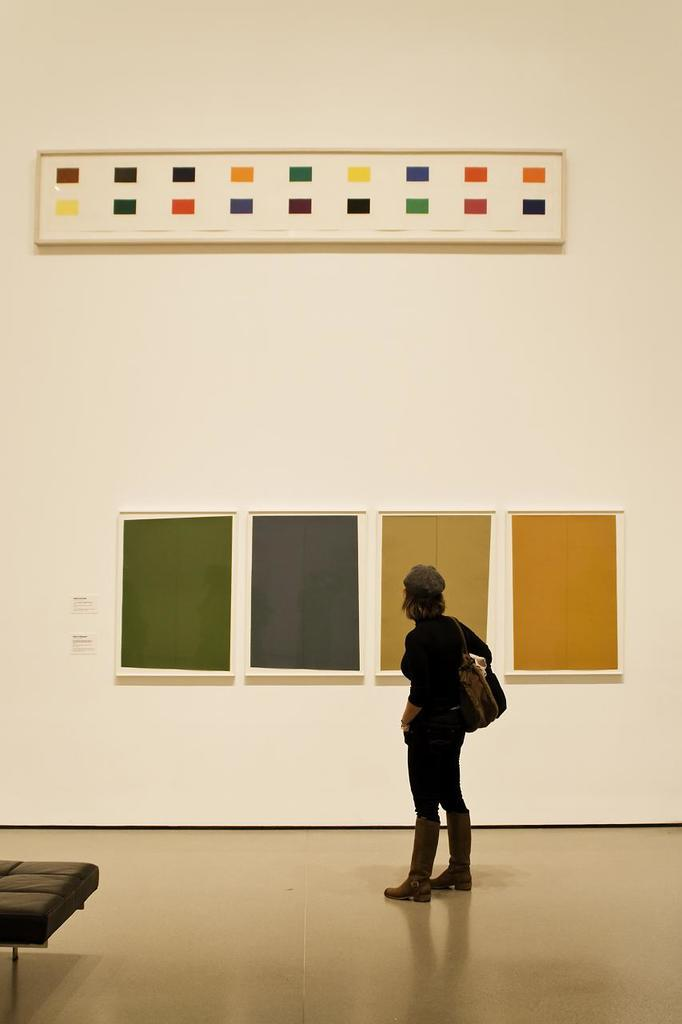What is the main subject of the image? There is a person standing in the center of the image. What is the person standing on? The person is standing on the floor. What can be seen in the background of the image? There is a wall and objects in the background of the image. Where is the chair located in the image? The chair is in the bottom left corner of the image. What type of necklace is the person wearing in the image? There is no necklace visible on the person in the image. What is the person sitting on in the image? The person is standing, not sitting, in the image. 